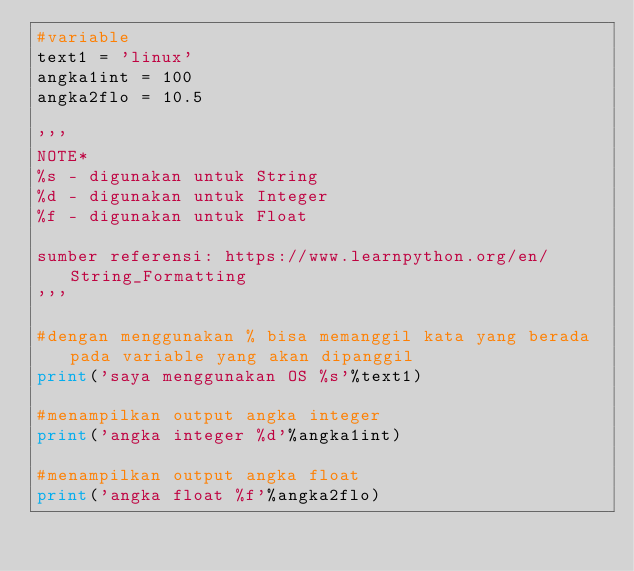Convert code to text. <code><loc_0><loc_0><loc_500><loc_500><_Python_>#variable
text1 = 'linux'
angka1int = 100
angka2flo = 10.5

'''
NOTE*
%s - digunakan untuk String
%d - digunakan untuk Integer
%f - digunakan untuk Float

sumber referensi: https://www.learnpython.org/en/String_Formatting
'''

#dengan menggunakan % bisa memanggil kata yang berada pada variable yang akan dipanggil
print('saya menggunakan OS %s'%text1)

#menampilkan output angka integer
print('angka integer %d'%angka1int)

#menampilkan output angka float
print('angka float %f'%angka2flo)</code> 